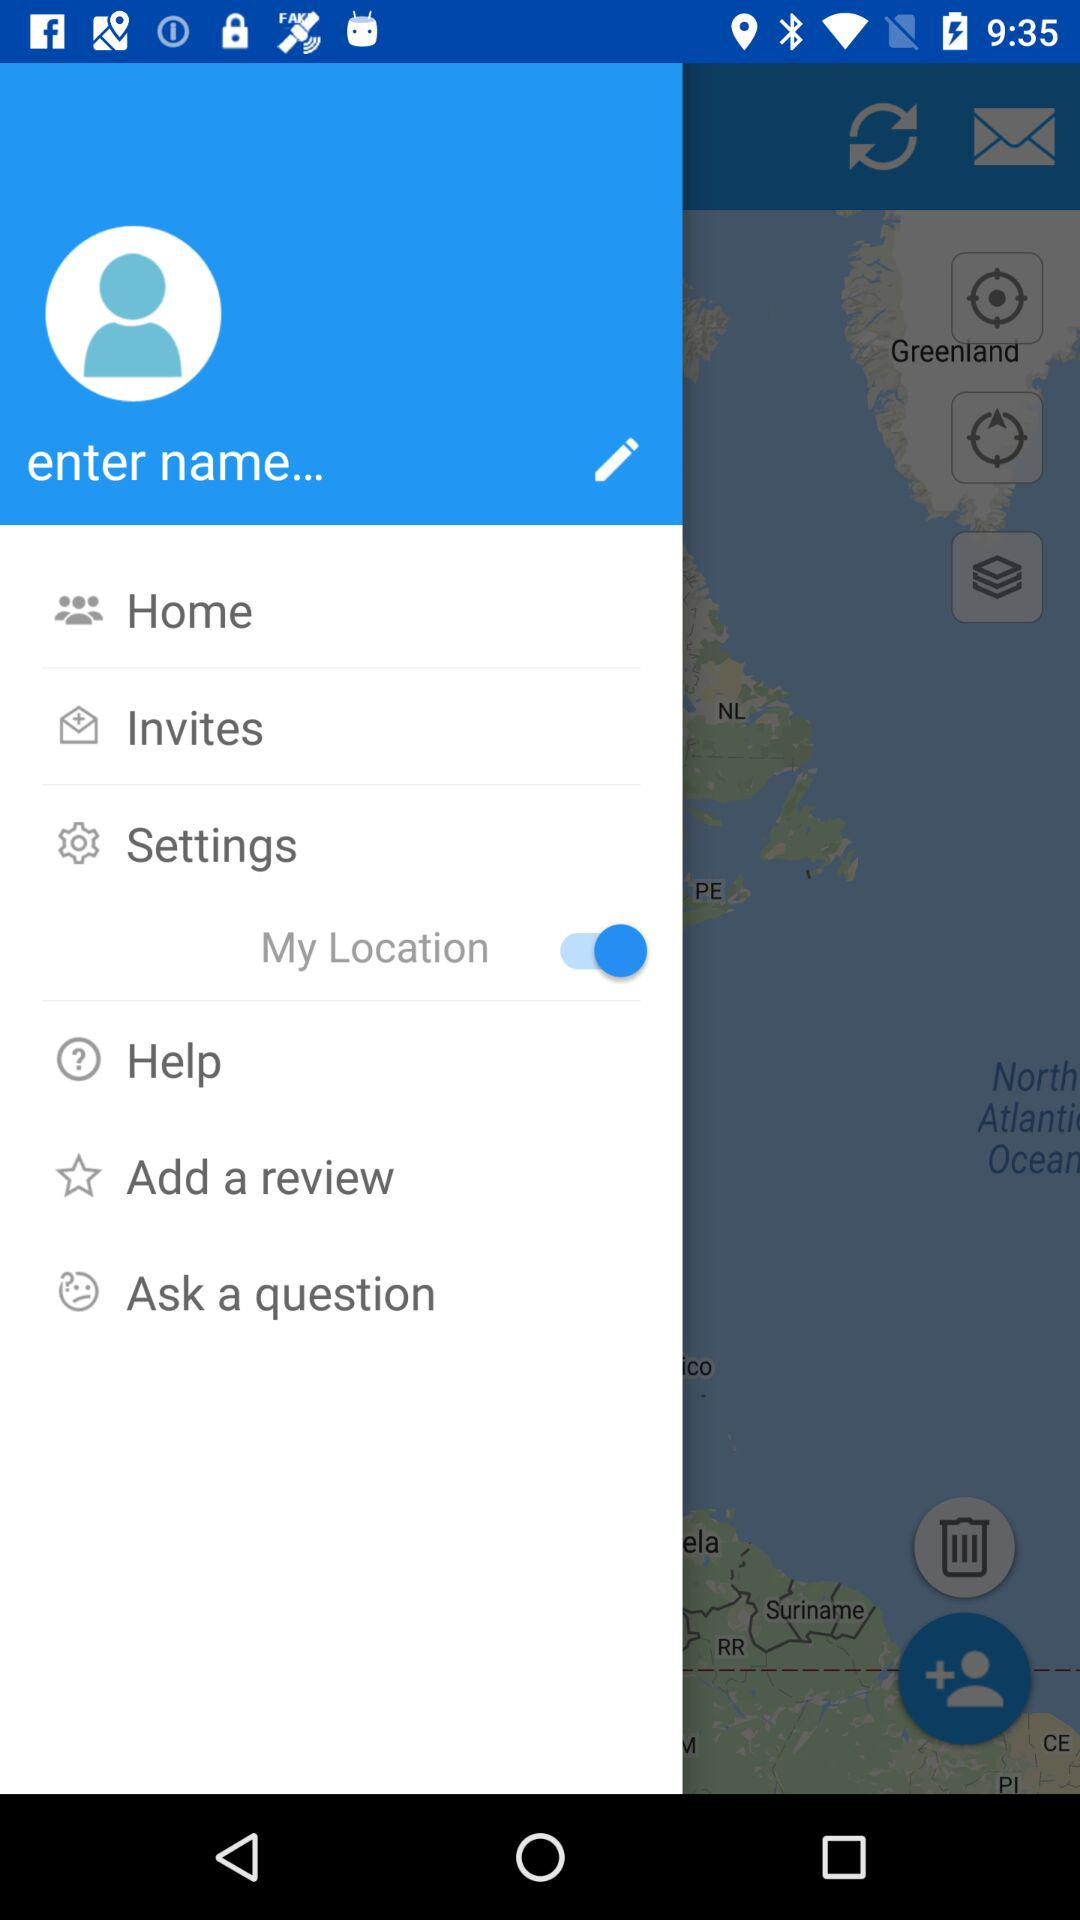What is the status of "My Location"? The status is on. 